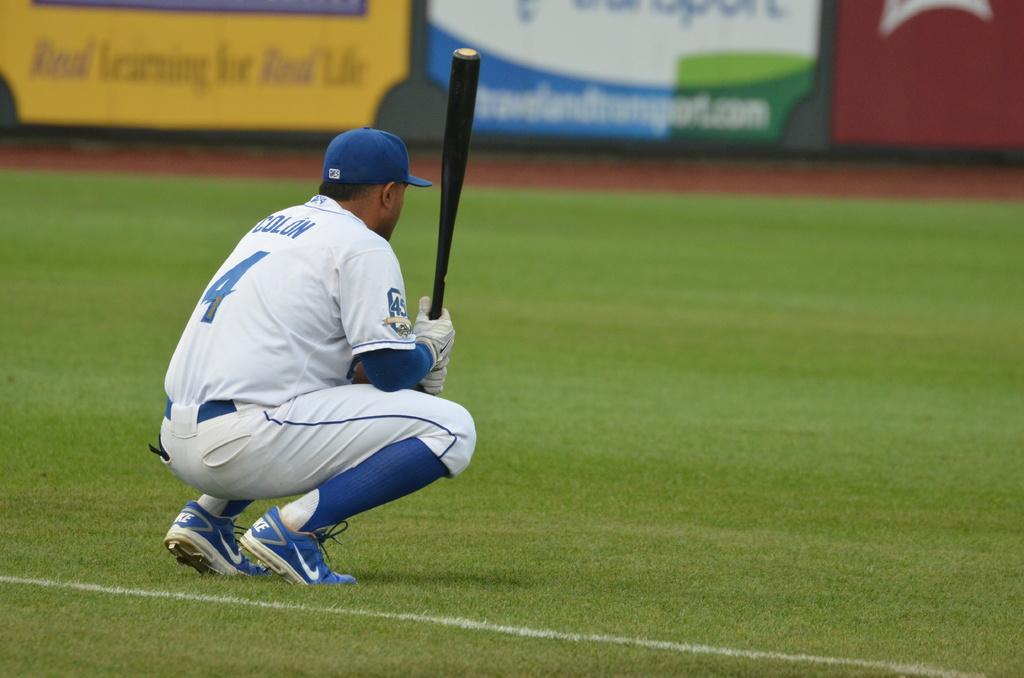Provide a one-sentence caption for the provided image. Player number 4 is crouched down holding a black bat. 